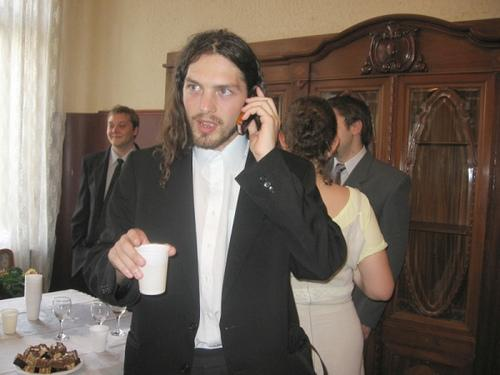What kind of telephone is being used? Please explain your reasoning. cellular. The person uses a cellphone. 